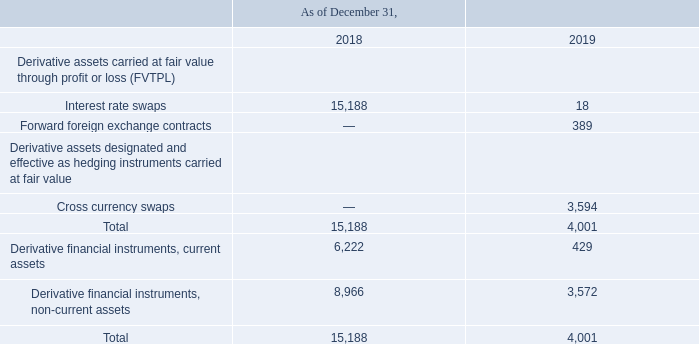GasLog Ltd. and its Subsidiaries
Notes to the consolidated financial statements (Continued)
For the years ended December 31, 2017, 2018 and 2019
(All amounts expressed in thousands of U.S. Dollars, except share and per share data)
26. Derivative Financial Instruments
The fair value of the derivative assets is as follows:
In which years was the fair value of the derivative assets recorded for? 2018, 2019. What was the fair value of cross currency swaps in 2019?
Answer scale should be: thousand. 3,594. What was the fair value of derivatives non-current assets in 2019?
Answer scale should be: thousand. 3,572. In which year was the fair value of  Interest rate swaps  higher? 15,188>18
Answer: 2018. What was the change in fair value of interest rate swaps from 2018 to 2019?
Answer scale should be: thousand. 18 - 15,188 
Answer: -15170. What was the percentage change in total fair value of the derivative assets from 2018 to 2019?
Answer scale should be: percent. (4,001 - 15,188)/15,188 
Answer: -73.66. 